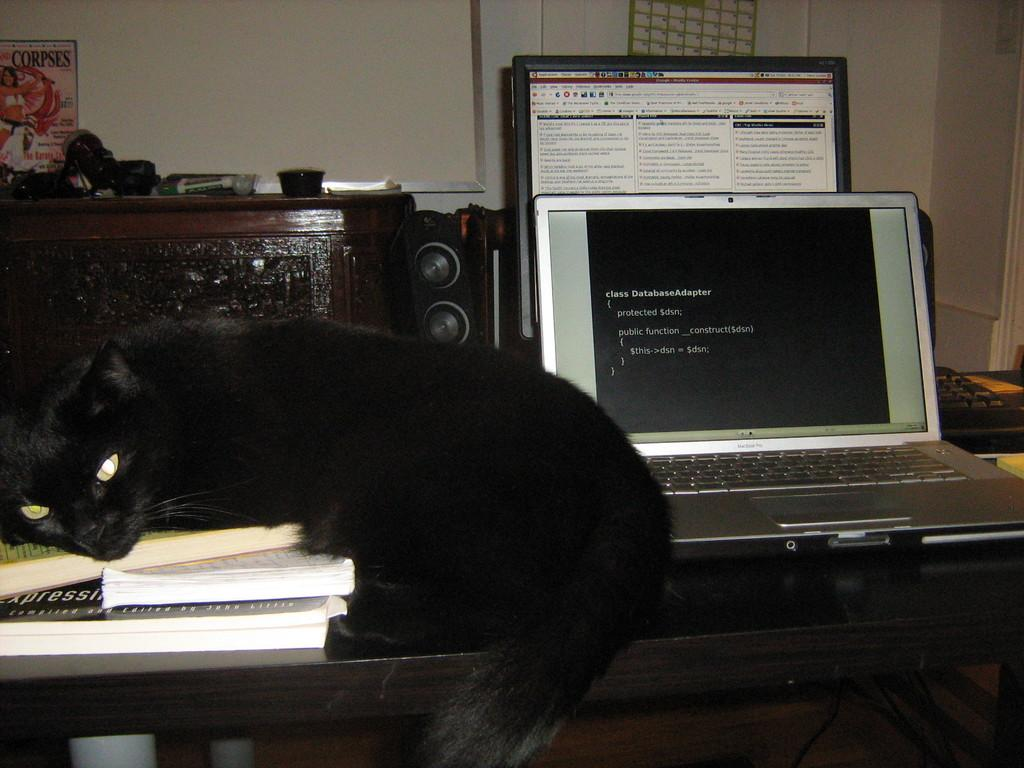What type of animal can be seen in the image? There is a cat in the image. What electronic device is present in the image? There is a laptop in the image. What other type of computer is visible in the image? There is a desktop in the image. What items can be seen on the table in the image? There are books on the table in the image. What piece of furniture is present in the image? There is a cupboard in the image. What is on top of the cupboard in the image? There are objects on the cupboard in the image. What can be seen in the background of the image? The wall is visible in the background of the image. How many ducks are sitting on the cat's head in the image? There are no ducks present in the image, and the cat's head is not visible. What type of pet is the cat interacting with in the image? There is no other pet present in the image; the cat is alone. 